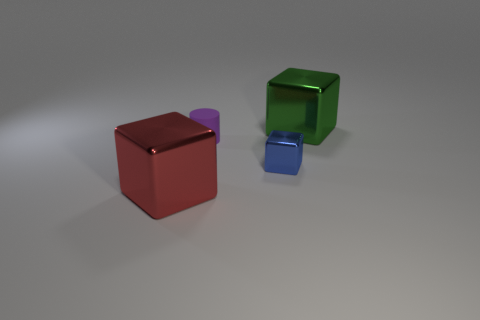Subtract all big metal blocks. How many blocks are left? 1 Add 2 tiny matte cylinders. How many objects exist? 6 Subtract all red blocks. How many blocks are left? 2 Subtract 2 blocks. How many blocks are left? 1 Subtract all tiny things. Subtract all small purple matte things. How many objects are left? 1 Add 1 blue shiny blocks. How many blue shiny blocks are left? 2 Add 1 small cylinders. How many small cylinders exist? 2 Subtract 0 purple balls. How many objects are left? 4 Subtract all cylinders. How many objects are left? 3 Subtract all gray cubes. Subtract all red balls. How many cubes are left? 3 